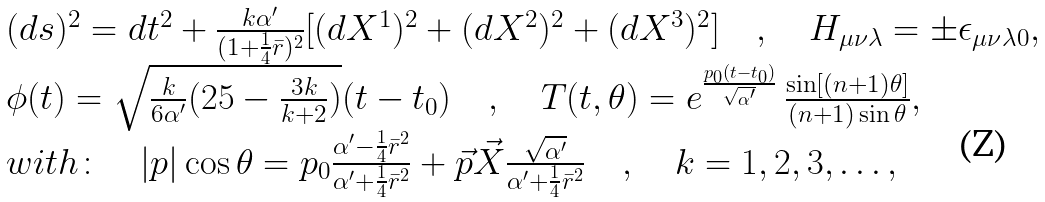Convert formula to latex. <formula><loc_0><loc_0><loc_500><loc_500>\begin{array} { l } { { ( d s ) ^ { 2 } = d t ^ { 2 } + \frac { k \alpha ^ { \prime } } { ( 1 + \frac { 1 } { 4 } \bar { r } ) ^ { 2 } } [ ( d X ^ { 1 } ) ^ { 2 } + ( d X ^ { 2 } ) ^ { 2 } + ( d X ^ { 3 } ) ^ { 2 } ] \quad , \quad H _ { \mu \nu \lambda } = \pm \epsilon _ { \mu \nu \lambda 0 } , } } \\ { { \phi ( t ) = \sqrt { \frac { k } { 6 \alpha ^ { \prime } } ( 2 5 - \frac { 3 k } { k + 2 } ) } ( t - t _ { 0 } ) \quad , \quad T ( t , \theta ) = e ^ { \frac { p _ { 0 } ( t - t _ { 0 } ) } { \sqrt { \alpha ^ { \prime } } } } \, \frac { \sin [ ( n + 1 ) \theta ] } { ( n + 1 ) \sin \theta } , } } \\ { { w i t h \colon \quad | p | \cos \theta = p _ { 0 } \frac { \alpha ^ { \prime } - \frac { 1 } { 4 } \bar { r } ^ { 2 } } { \alpha ^ { \prime } + \frac { 1 } { 4 } \bar { r } ^ { 2 } } + \vec { p } \vec { X } \frac { \sqrt { \alpha ^ { \prime } } } { \alpha ^ { \prime } + \frac { 1 } { 4 } \bar { r } ^ { 2 } } \quad , \quad k = 1 , 2 , 3 , \dots , } } \end{array}</formula> 